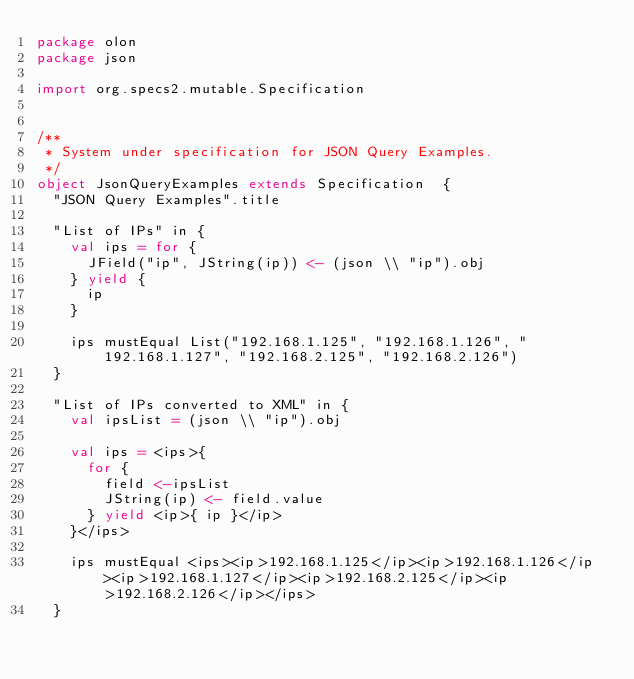Convert code to text. <code><loc_0><loc_0><loc_500><loc_500><_Scala_>package olon
package json

import org.specs2.mutable.Specification


/**
 * System under specification for JSON Query Examples.
 */
object JsonQueryExamples extends Specification  {
  "JSON Query Examples".title

  "List of IPs" in {
    val ips = for {
      JField("ip", JString(ip)) <- (json \\ "ip").obj
    } yield {
      ip
    }

    ips mustEqual List("192.168.1.125", "192.168.1.126", "192.168.1.127", "192.168.2.125", "192.168.2.126")
  }

  "List of IPs converted to XML" in {
    val ipsList = (json \\ "ip").obj

    val ips = <ips>{
      for {
        field <-ipsList
        JString(ip) <- field.value
      } yield <ip>{ ip }</ip>
    }</ips>

    ips mustEqual <ips><ip>192.168.1.125</ip><ip>192.168.1.126</ip><ip>192.168.1.127</ip><ip>192.168.2.125</ip><ip>192.168.2.126</ip></ips>
  }
</code> 